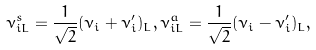<formula> <loc_0><loc_0><loc_500><loc_500>\nu _ { i L } ^ { s } = \frac { 1 } { \sqrt { 2 } } ( \nu _ { i } + \nu _ { i } ^ { \prime } ) _ { L } , \nu _ { i L } ^ { a } = \frac { 1 } { \sqrt { 2 } } ( \nu _ { i } - \nu _ { i } ^ { \prime } ) _ { L } ,</formula> 